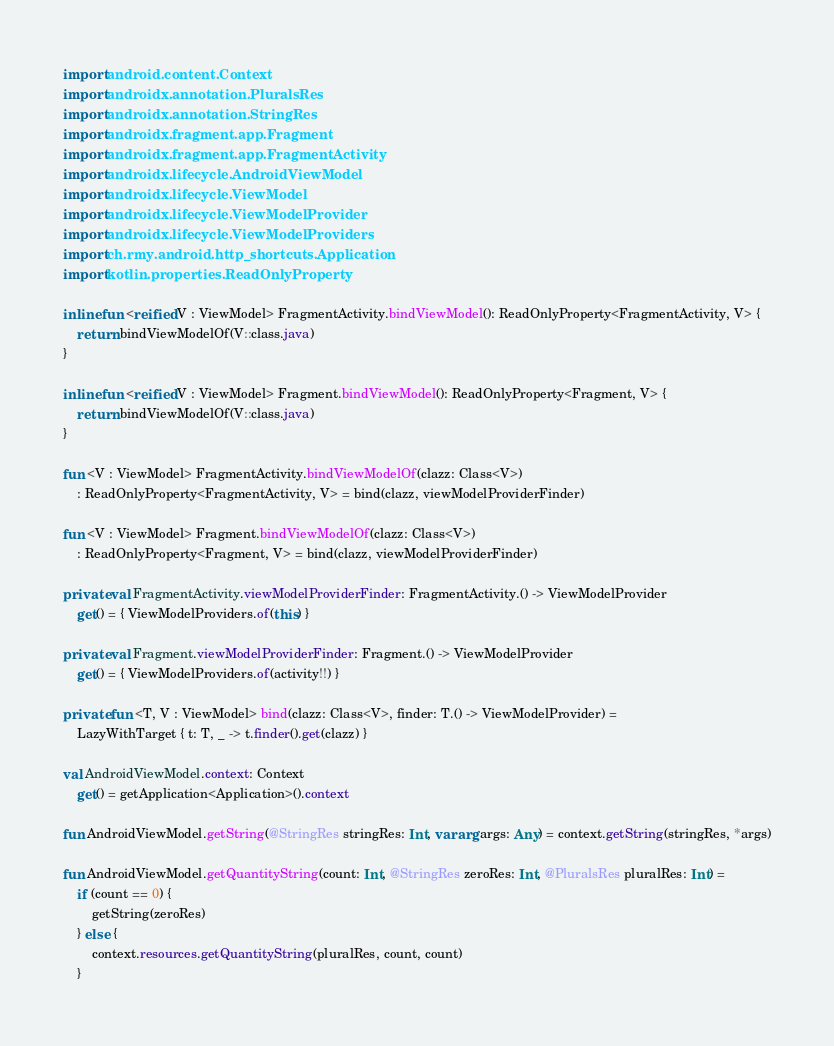<code> <loc_0><loc_0><loc_500><loc_500><_Kotlin_>import android.content.Context
import androidx.annotation.PluralsRes
import androidx.annotation.StringRes
import androidx.fragment.app.Fragment
import androidx.fragment.app.FragmentActivity
import androidx.lifecycle.AndroidViewModel
import androidx.lifecycle.ViewModel
import androidx.lifecycle.ViewModelProvider
import androidx.lifecycle.ViewModelProviders
import ch.rmy.android.http_shortcuts.Application
import kotlin.properties.ReadOnlyProperty

inline fun <reified V : ViewModel> FragmentActivity.bindViewModel(): ReadOnlyProperty<FragmentActivity, V> {
    return bindViewModelOf(V::class.java)
}

inline fun <reified V : ViewModel> Fragment.bindViewModel(): ReadOnlyProperty<Fragment, V> {
    return bindViewModelOf(V::class.java)
}

fun <V : ViewModel> FragmentActivity.bindViewModelOf(clazz: Class<V>)
    : ReadOnlyProperty<FragmentActivity, V> = bind(clazz, viewModelProviderFinder)

fun <V : ViewModel> Fragment.bindViewModelOf(clazz: Class<V>)
    : ReadOnlyProperty<Fragment, V> = bind(clazz, viewModelProviderFinder)

private val FragmentActivity.viewModelProviderFinder: FragmentActivity.() -> ViewModelProvider
    get() = { ViewModelProviders.of(this) }

private val Fragment.viewModelProviderFinder: Fragment.() -> ViewModelProvider
    get() = { ViewModelProviders.of(activity!!) }

private fun <T, V : ViewModel> bind(clazz: Class<V>, finder: T.() -> ViewModelProvider) =
    LazyWithTarget { t: T, _ -> t.finder().get(clazz) }

val AndroidViewModel.context: Context
    get() = getApplication<Application>().context

fun AndroidViewModel.getString(@StringRes stringRes: Int, vararg args: Any) = context.getString(stringRes, *args)

fun AndroidViewModel.getQuantityString(count: Int, @StringRes zeroRes: Int, @PluralsRes pluralRes: Int) =
    if (count == 0) {
        getString(zeroRes)
    } else {
        context.resources.getQuantityString(pluralRes, count, count)
    }</code> 